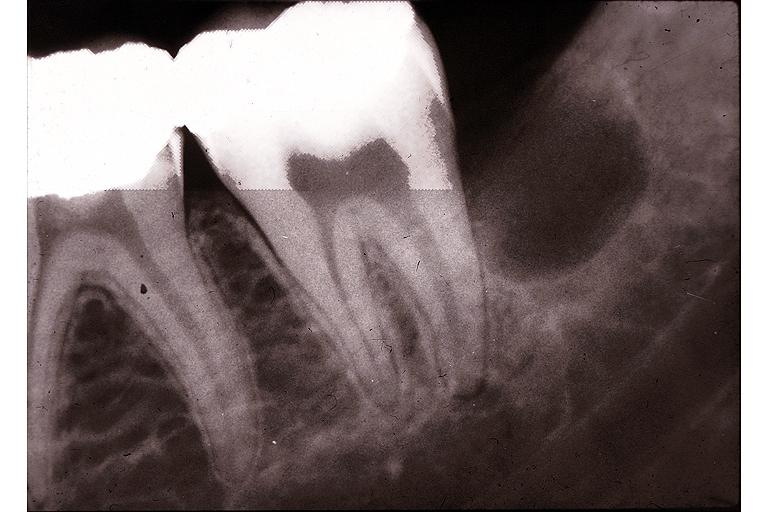what is present?
Answer the question using a single word or phrase. Oral 